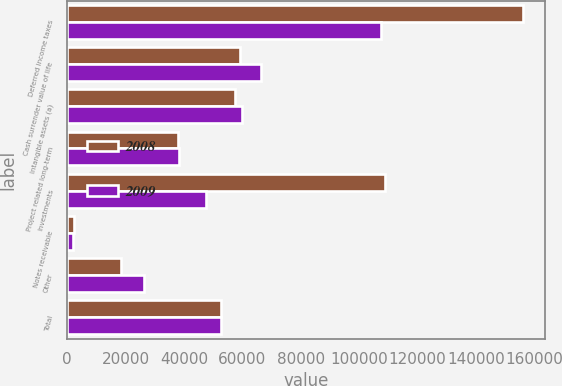Convert chart to OTSL. <chart><loc_0><loc_0><loc_500><loc_500><stacked_bar_chart><ecel><fcel>Deferred income taxes<fcel>Cash surrender value of life<fcel>Intangible assets (a)<fcel>Project related long-term<fcel>Investments<fcel>Notes receivable<fcel>Other<fcel>Total<nl><fcel>2008<fcel>155968<fcel>59236<fcel>57459<fcel>37887<fcel>108895<fcel>2130<fcel>18398<fcel>52490<nl><fcel>2009<fcel>107597<fcel>66325<fcel>59903<fcel>38127<fcel>47521<fcel>1969<fcel>26362<fcel>52490<nl></chart> 